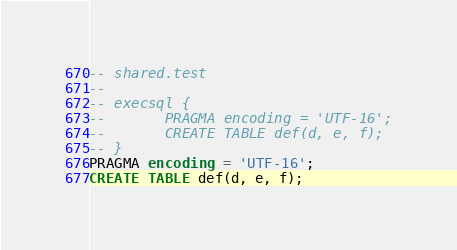Convert code to text. <code><loc_0><loc_0><loc_500><loc_500><_SQL_>-- shared.test
-- 
-- execsql {
--       PRAGMA encoding = 'UTF-16';
--       CREATE TABLE def(d, e, f);
-- }
PRAGMA encoding = 'UTF-16';
CREATE TABLE def(d, e, f);</code> 